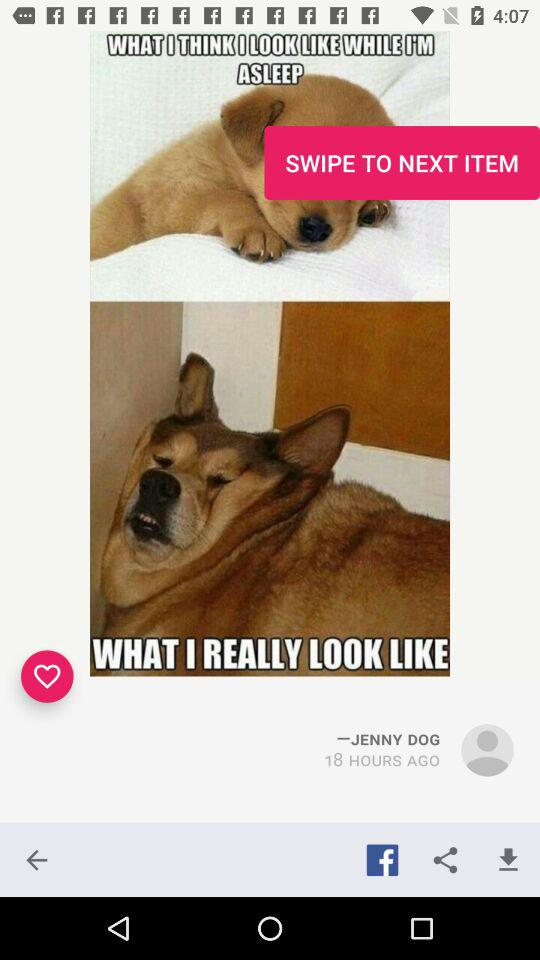Who is the publisher of this pic? The publisher is Jenny Dog. 